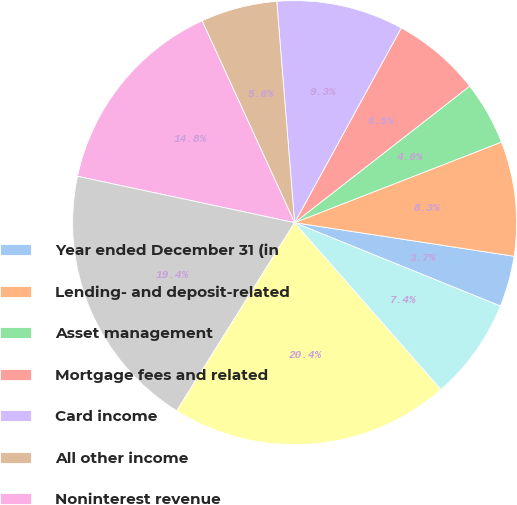Convert chart. <chart><loc_0><loc_0><loc_500><loc_500><pie_chart><fcel>Year ended December 31 (in<fcel>Lending- and deposit-related<fcel>Asset management<fcel>Mortgage fees and related<fcel>Card income<fcel>All other income<fcel>Noninterest revenue<fcel>Net interest income<fcel>Total net revenue<fcel>Provision for credit losses<nl><fcel>3.71%<fcel>8.33%<fcel>4.63%<fcel>6.48%<fcel>9.26%<fcel>5.56%<fcel>14.81%<fcel>19.44%<fcel>20.37%<fcel>7.41%<nl></chart> 